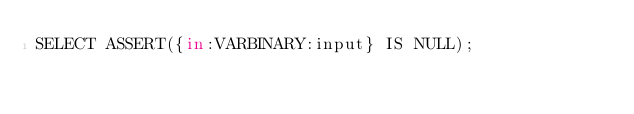<code> <loc_0><loc_0><loc_500><loc_500><_SQL_>SELECT ASSERT({in:VARBINARY:input} IS NULL);</code> 